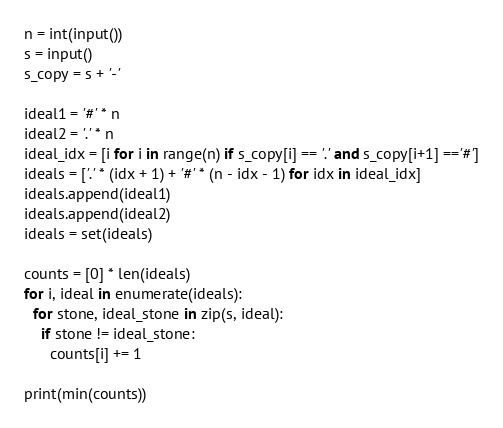<code> <loc_0><loc_0><loc_500><loc_500><_Python_>n = int(input())
s = input()
s_copy = s + '-'

ideal1 = '#' * n
ideal2 = '.' * n
ideal_idx = [i for i in range(n) if s_copy[i] == '.' and s_copy[i+1] =='#']
ideals = ['.' * (idx + 1) + '#' * (n - idx - 1) for idx in ideal_idx]
ideals.append(ideal1)
ideals.append(ideal2)
ideals = set(ideals)

counts = [0] * len(ideals)
for i, ideal in enumerate(ideals):
  for stone, ideal_stone in zip(s, ideal):
    if stone != ideal_stone:
      counts[i] += 1

print(min(counts))</code> 